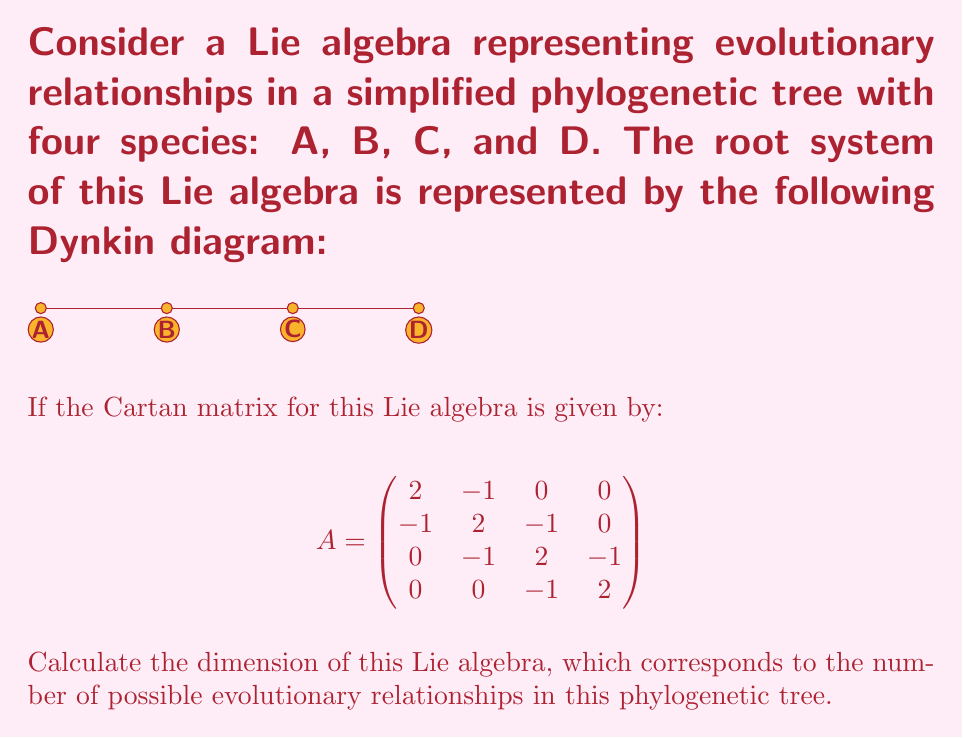Give your solution to this math problem. To solve this problem, we'll follow these steps:

1) The dimension of a Lie algebra is given by the formula:
   $$\dim(\mathfrak{g}) = n + |\Phi|$$
   where $n$ is the rank of the algebra (number of nodes in the Dynkin diagram) and $|\Phi|$ is the number of roots.

2) From the Dynkin diagram, we can see that $n = 4$.

3) For a simple Lie algebra, the number of roots is given by:
   $$|\Phi| = h \cdot n$$
   where $h$ is the Coxeter number.

4) The Coxeter number can be calculated from the Cartan matrix using the formula:
   $$h = \max_{i,j} (m_{ij})$$
   where $m_{ij}$ are the entries of the matrix $M = 2I - A$.

5) Let's calculate $M$:
   $$
   M = 2I - A = \begin{pmatrix}
   0 & 1 & 0 & 0 \\
   1 & 0 & 1 & 0 \\
   0 & 1 & 0 & 1 \\
   0 & 0 & 1 & 0
   \end{pmatrix}
   $$

6) The maximum entry in $M$ is 1, so $h = 1 + 1 = 2$.

7) Now we can calculate the number of roots:
   $$|\Phi| = h \cdot n = 2 \cdot 4 = 8$$

8) Finally, we can calculate the dimension:
   $$\dim(\mathfrak{g}) = n + |\Phi| = 4 + 8 = 12$$

This dimension represents the number of possible evolutionary relationships in the phylogenetic tree, including both the direct relationships between adjacent species and the indirect relationships across the tree.
Answer: 12 